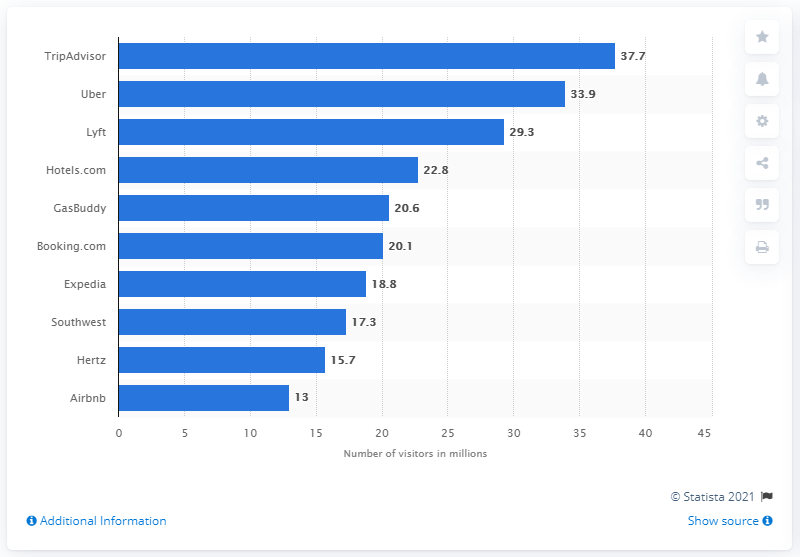Outline some significant characteristics in this image. As of April 2018, the online audience of Expedia was 18.8 million. As of April 2018, TripAdvisor received a total of 37.7 unique visitors. 